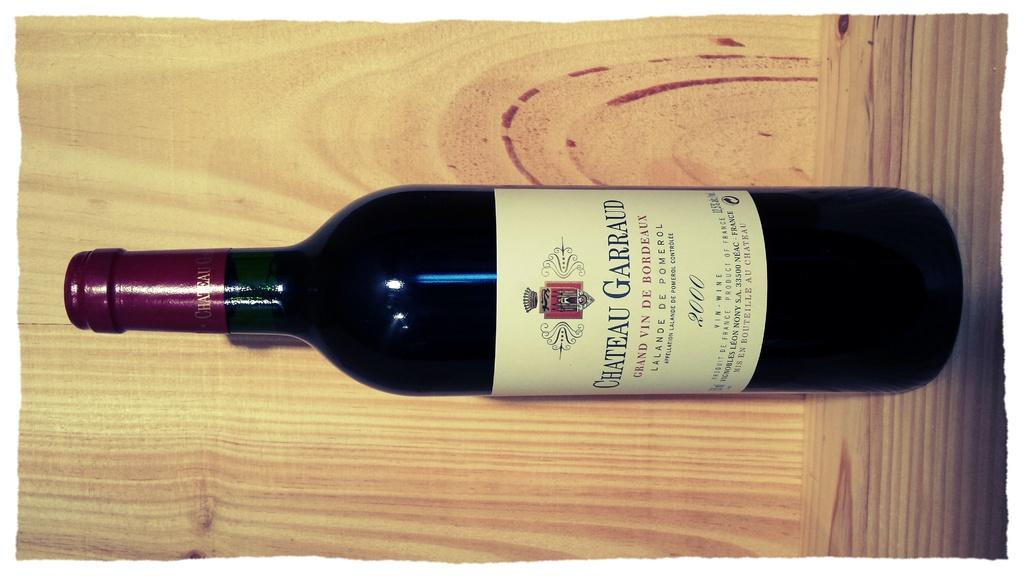<image>
Summarize the visual content of the image. the word chateau is on a wine bottle 